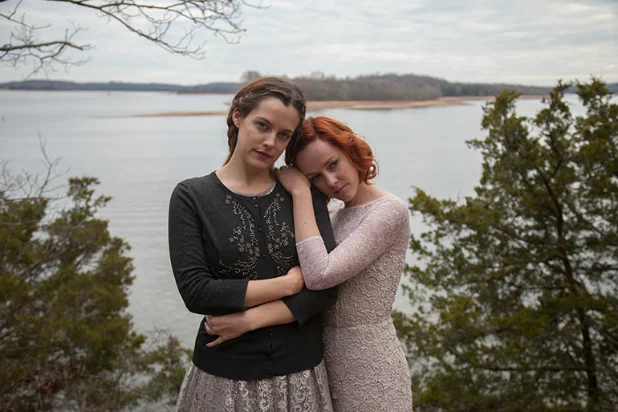Describe how the emotional aura of this scene is depicted through the natural setting. The overcast sky and remote natural setting contribute to the serene yet introspective aura of the scene. The expansive body of water and distant treeline echo feelings of vastness and solitude, which correlate with the quiet and reflective moods of the subjects. The cool and muted tones of the environment emphasize a sense of calmness and introspection, reflecting the internal states of the women as they stand together in contemplation. 